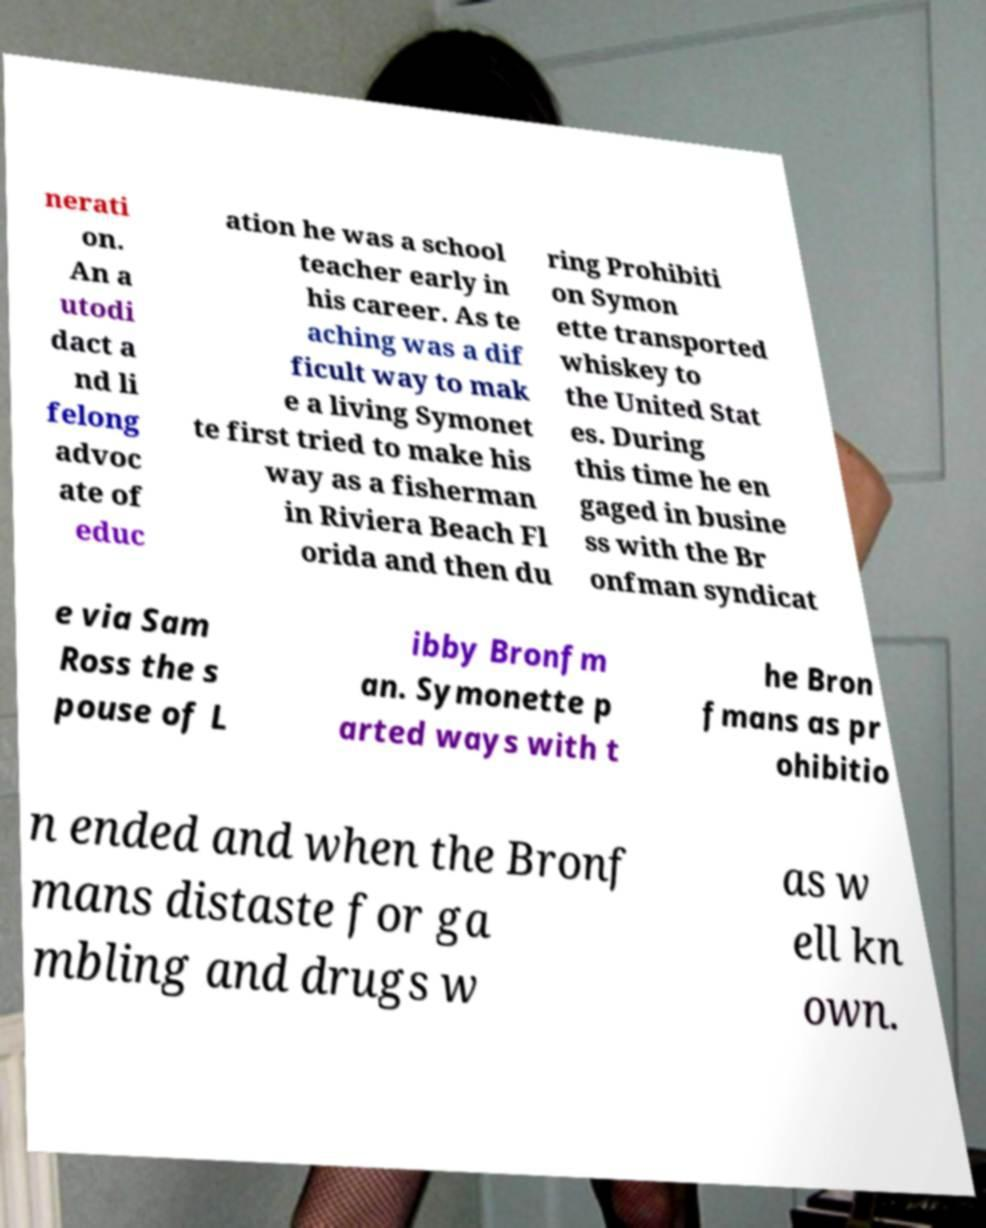Could you extract and type out the text from this image? nerati on. An a utodi dact a nd li felong advoc ate of educ ation he was a school teacher early in his career. As te aching was a dif ficult way to mak e a living Symonet te first tried to make his way as a fisherman in Riviera Beach Fl orida and then du ring Prohibiti on Symon ette transported whiskey to the United Stat es. During this time he en gaged in busine ss with the Br onfman syndicat e via Sam Ross the s pouse of L ibby Bronfm an. Symonette p arted ways with t he Bron fmans as pr ohibitio n ended and when the Bronf mans distaste for ga mbling and drugs w as w ell kn own. 